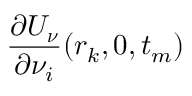<formula> <loc_0><loc_0><loc_500><loc_500>{ \frac { \partial U _ { \boldsymbol \nu } } { \partial \nu _ { i } } } ( r _ { k } , 0 , t _ { m } )</formula> 